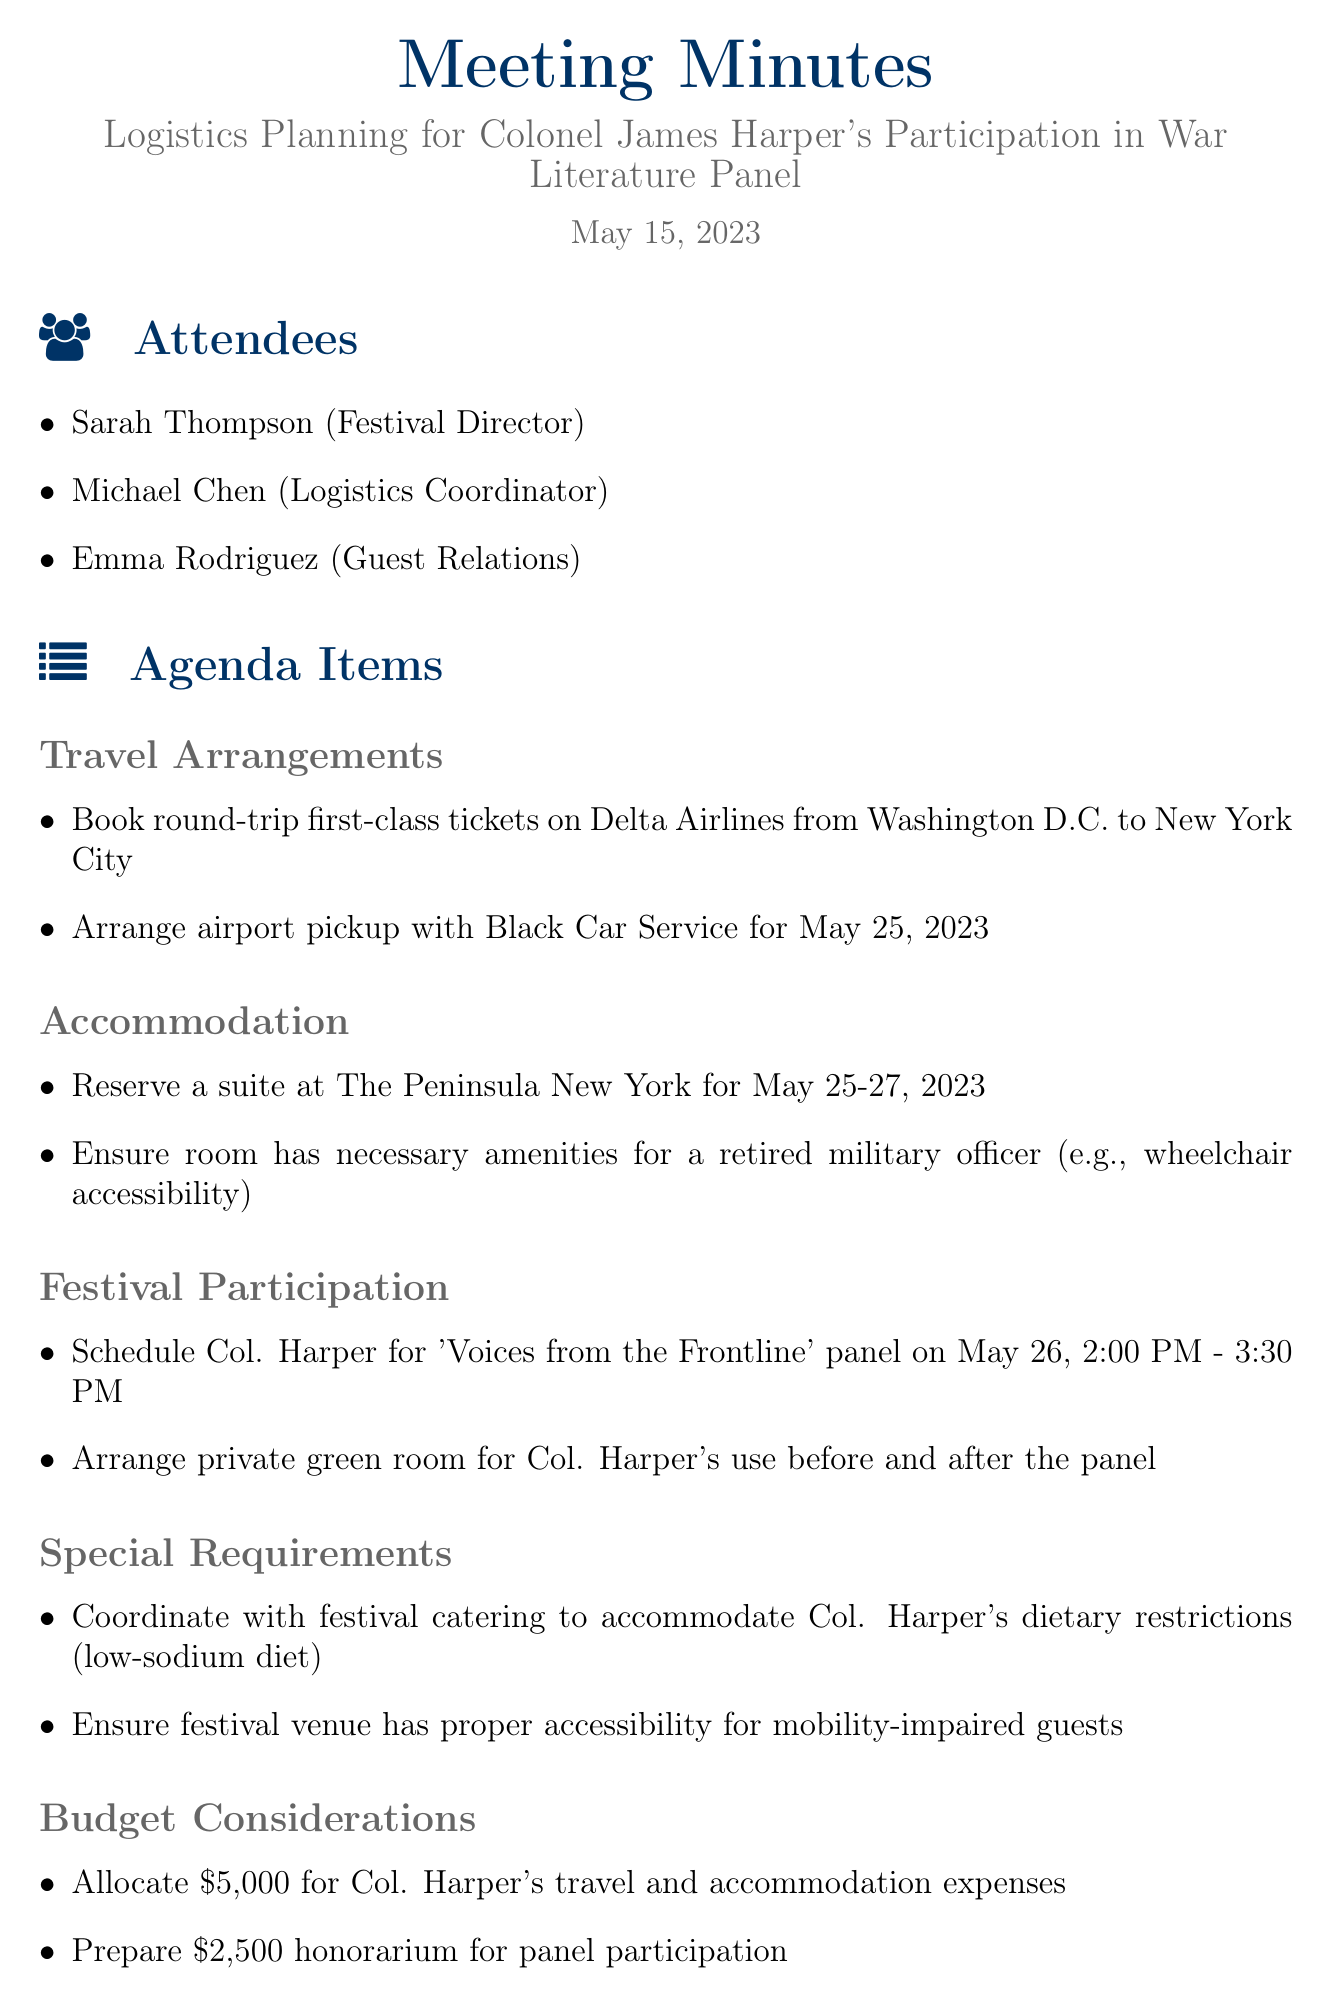what is the date of the meeting? The date of the meeting is clearly stated in the document as May 15, 2023.
Answer: May 15, 2023 who is the logistics coordinator? The logistics coordinator is one of the attendees listed in the document, identified as Michael Chen.
Answer: Michael Chen what airline is used for travel arrangements? The document specifies that Delta Airlines is the airline chosen for booking the round-trip tickets.
Answer: Delta Airlines what is the honorarium amount for Colonel Harper's participation? The document mentions that an honorarium of $2,500 is prepared for Colonel Harper's panel participation.
Answer: $2,500 when is Colonel Harper scheduled to participate in the panel? The scheduled time for Colonel Harper's panel participation is indicated in the agenda items, stating May 26, 2:00 PM - 3:30 PM.
Answer: May 26, 2:00 PM - 3:30 PM what type of room is reserved for Colonel Harper? The document specifies that a suite at The Peninsula New York is reserved for Colonel Harper during his stay.
Answer: Suite at The Peninsula New York how many days will Colonel Harper be accommodated? The document indicates that Colonel Harper's accommodation is booked from May 25 to May 27, allowing for a total of two nights.
Answer: Two nights what dietary restriction does Colonel Harper have? The meeting minutes note that Colonel Harper requires a low-sodium diet, which must be accommodated by the catering service.
Answer: Low-sodium diet who is responsible for confirming travel bookings? The action item assigns the responsibility of confirming travel bookings to Michael.
Answer: Michael 